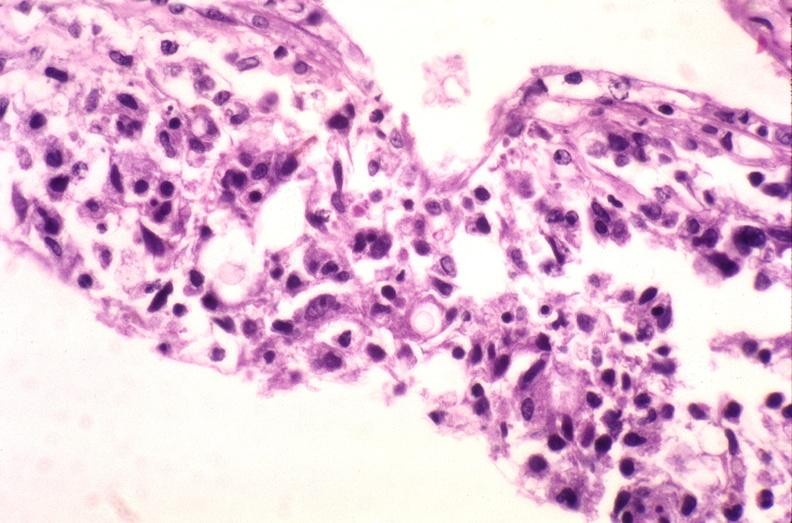s candida in peripheral blood present?
Answer the question using a single word or phrase. No 